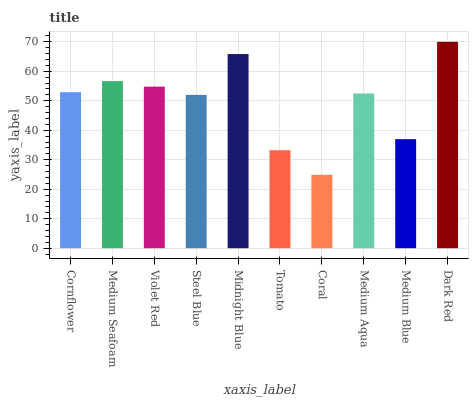Is Coral the minimum?
Answer yes or no. Yes. Is Dark Red the maximum?
Answer yes or no. Yes. Is Medium Seafoam the minimum?
Answer yes or no. No. Is Medium Seafoam the maximum?
Answer yes or no. No. Is Medium Seafoam greater than Cornflower?
Answer yes or no. Yes. Is Cornflower less than Medium Seafoam?
Answer yes or no. Yes. Is Cornflower greater than Medium Seafoam?
Answer yes or no. No. Is Medium Seafoam less than Cornflower?
Answer yes or no. No. Is Cornflower the high median?
Answer yes or no. Yes. Is Medium Aqua the low median?
Answer yes or no. Yes. Is Midnight Blue the high median?
Answer yes or no. No. Is Violet Red the low median?
Answer yes or no. No. 